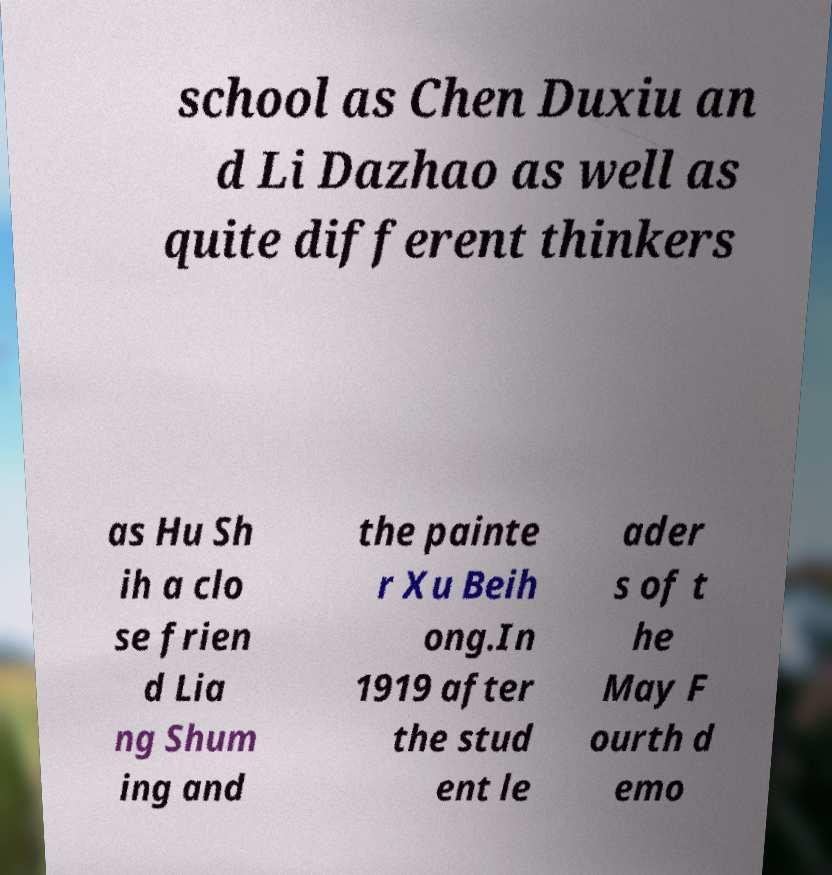Could you extract and type out the text from this image? school as Chen Duxiu an d Li Dazhao as well as quite different thinkers as Hu Sh ih a clo se frien d Lia ng Shum ing and the painte r Xu Beih ong.In 1919 after the stud ent le ader s of t he May F ourth d emo 